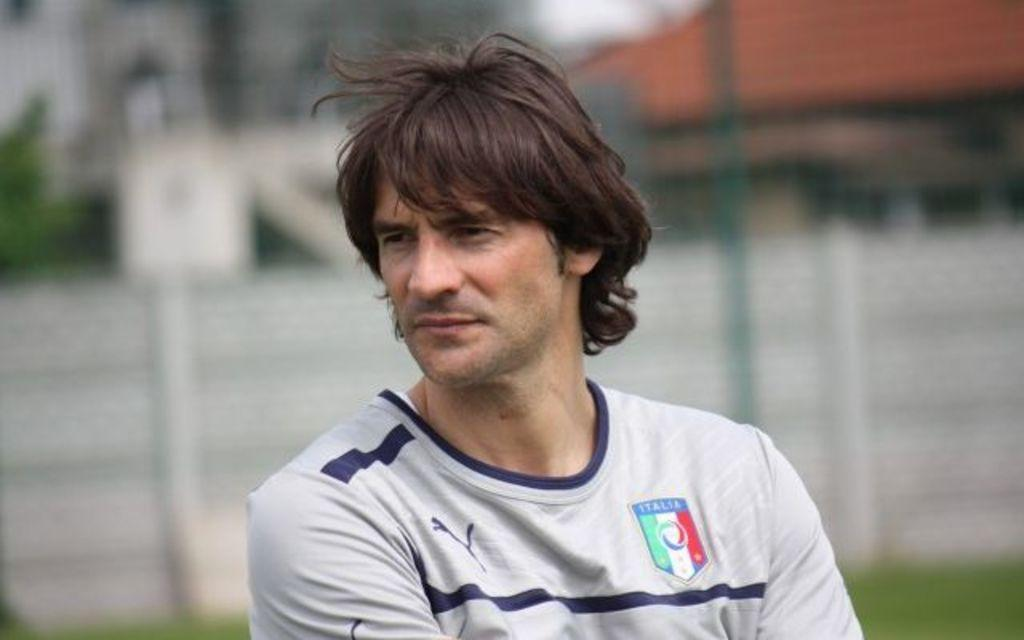<image>
Provide a brief description of the given image. A player wears a white jersey with an emblem that says Italia on it. 